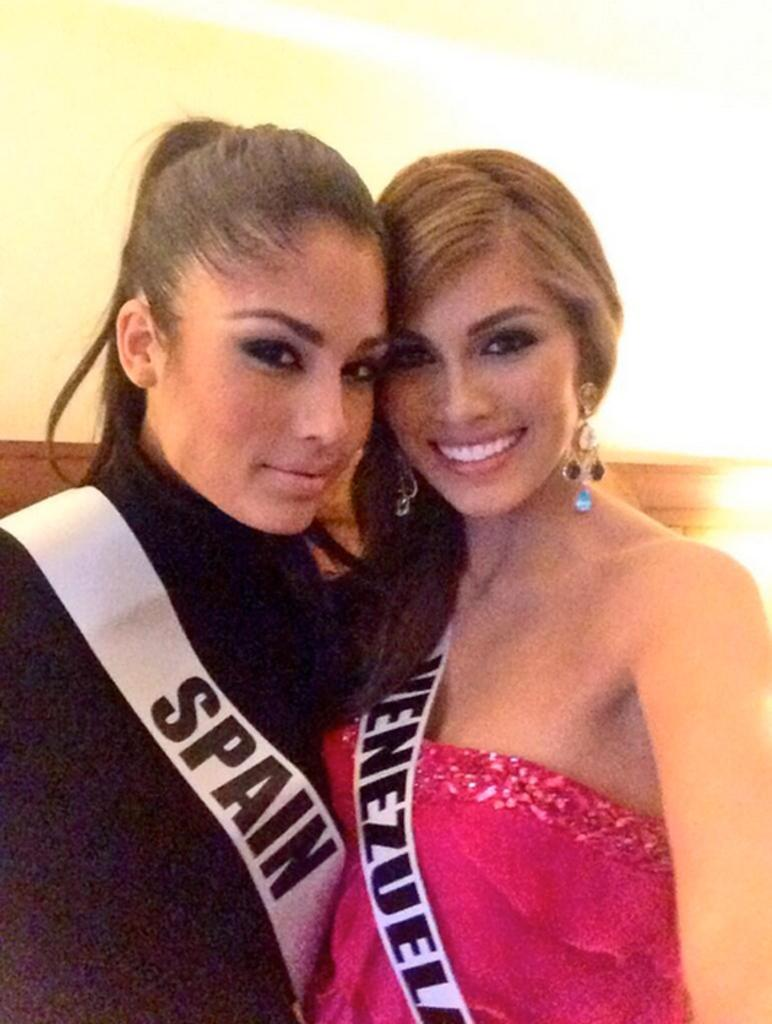<image>
Relay a brief, clear account of the picture shown. Two attractive young women, one wearing a sash saying Spain the other one that says Venezuela, smile at the camera. 